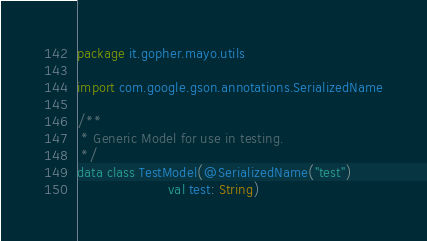<code> <loc_0><loc_0><loc_500><loc_500><_Kotlin_>package it.gopher.mayo.utils

import com.google.gson.annotations.SerializedName

/**
 * Generic Model for use in testing.
 */
data class TestModel(@SerializedName("test")
                     val test: String)</code> 